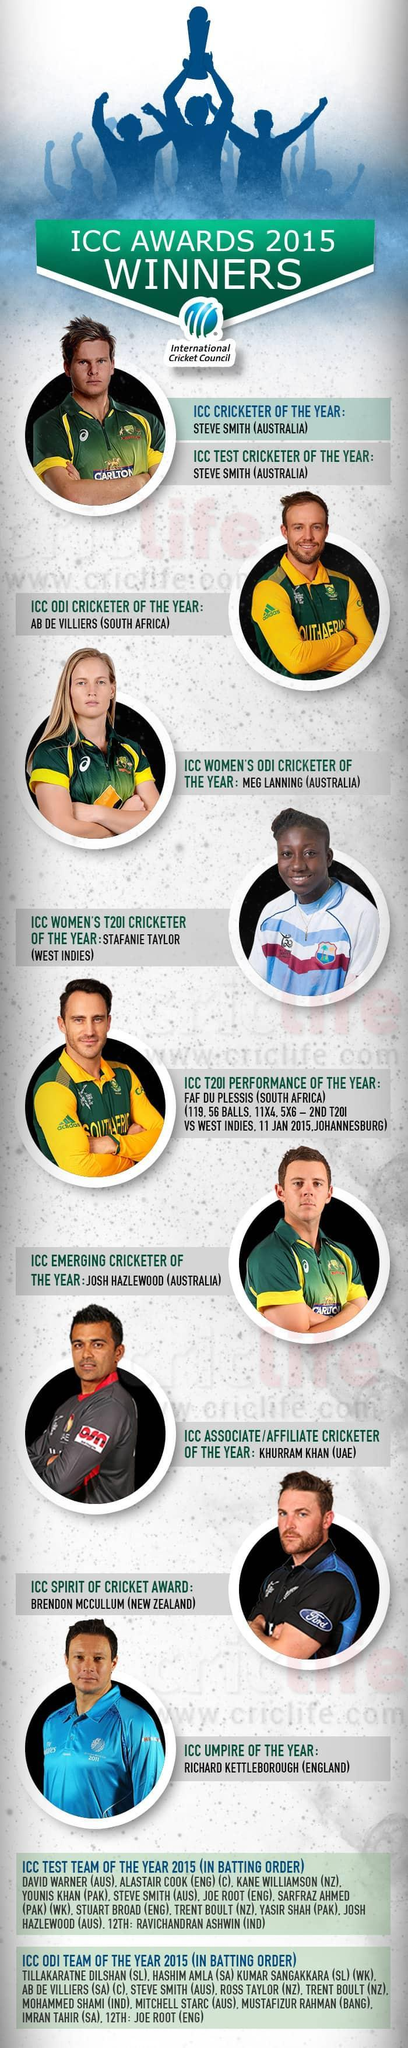Who are the women players who won the ICC awards 2015?
Answer the question with a short phrase. Meg Lanning, Stafanie Taylor Which country bagged the highest number of ICC awards? Australia 